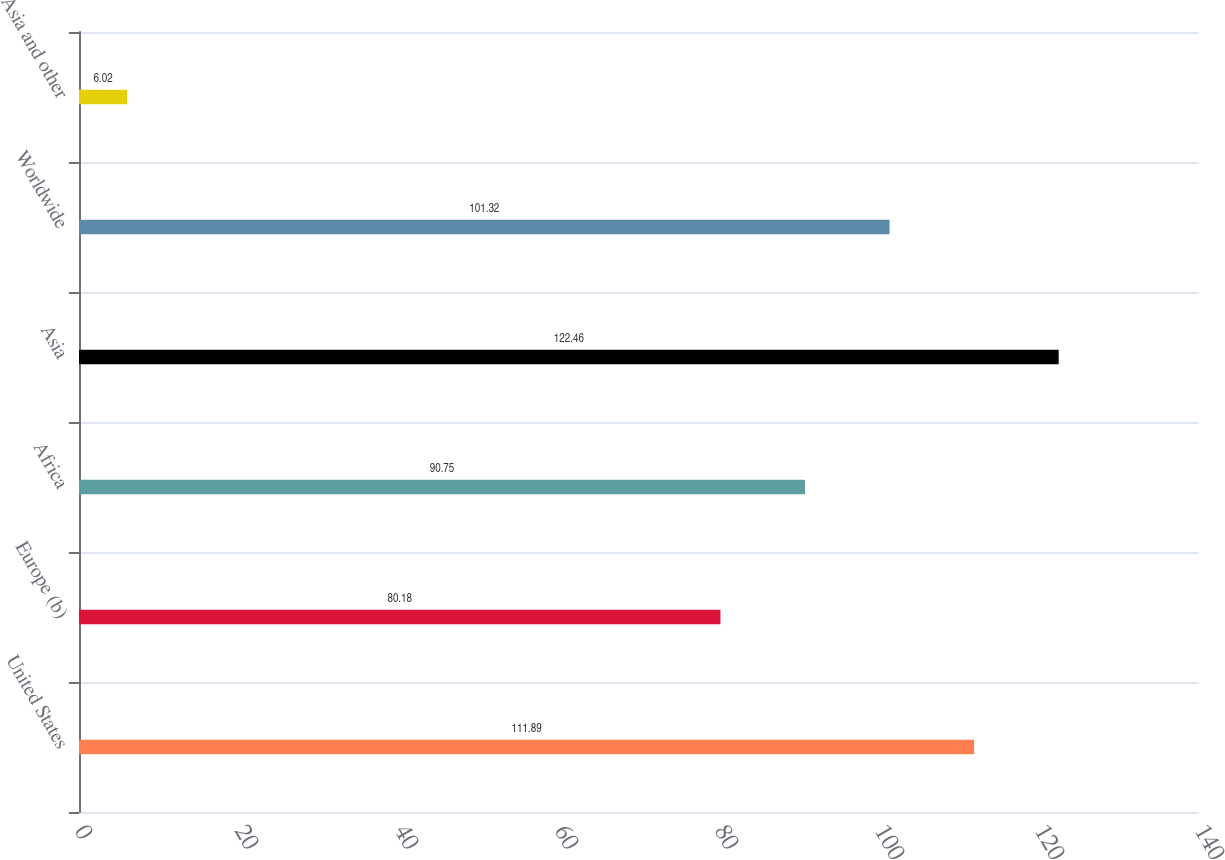<chart> <loc_0><loc_0><loc_500><loc_500><bar_chart><fcel>United States<fcel>Europe (b)<fcel>Africa<fcel>Asia<fcel>Worldwide<fcel>Asia and other<nl><fcel>111.89<fcel>80.18<fcel>90.75<fcel>122.46<fcel>101.32<fcel>6.02<nl></chart> 